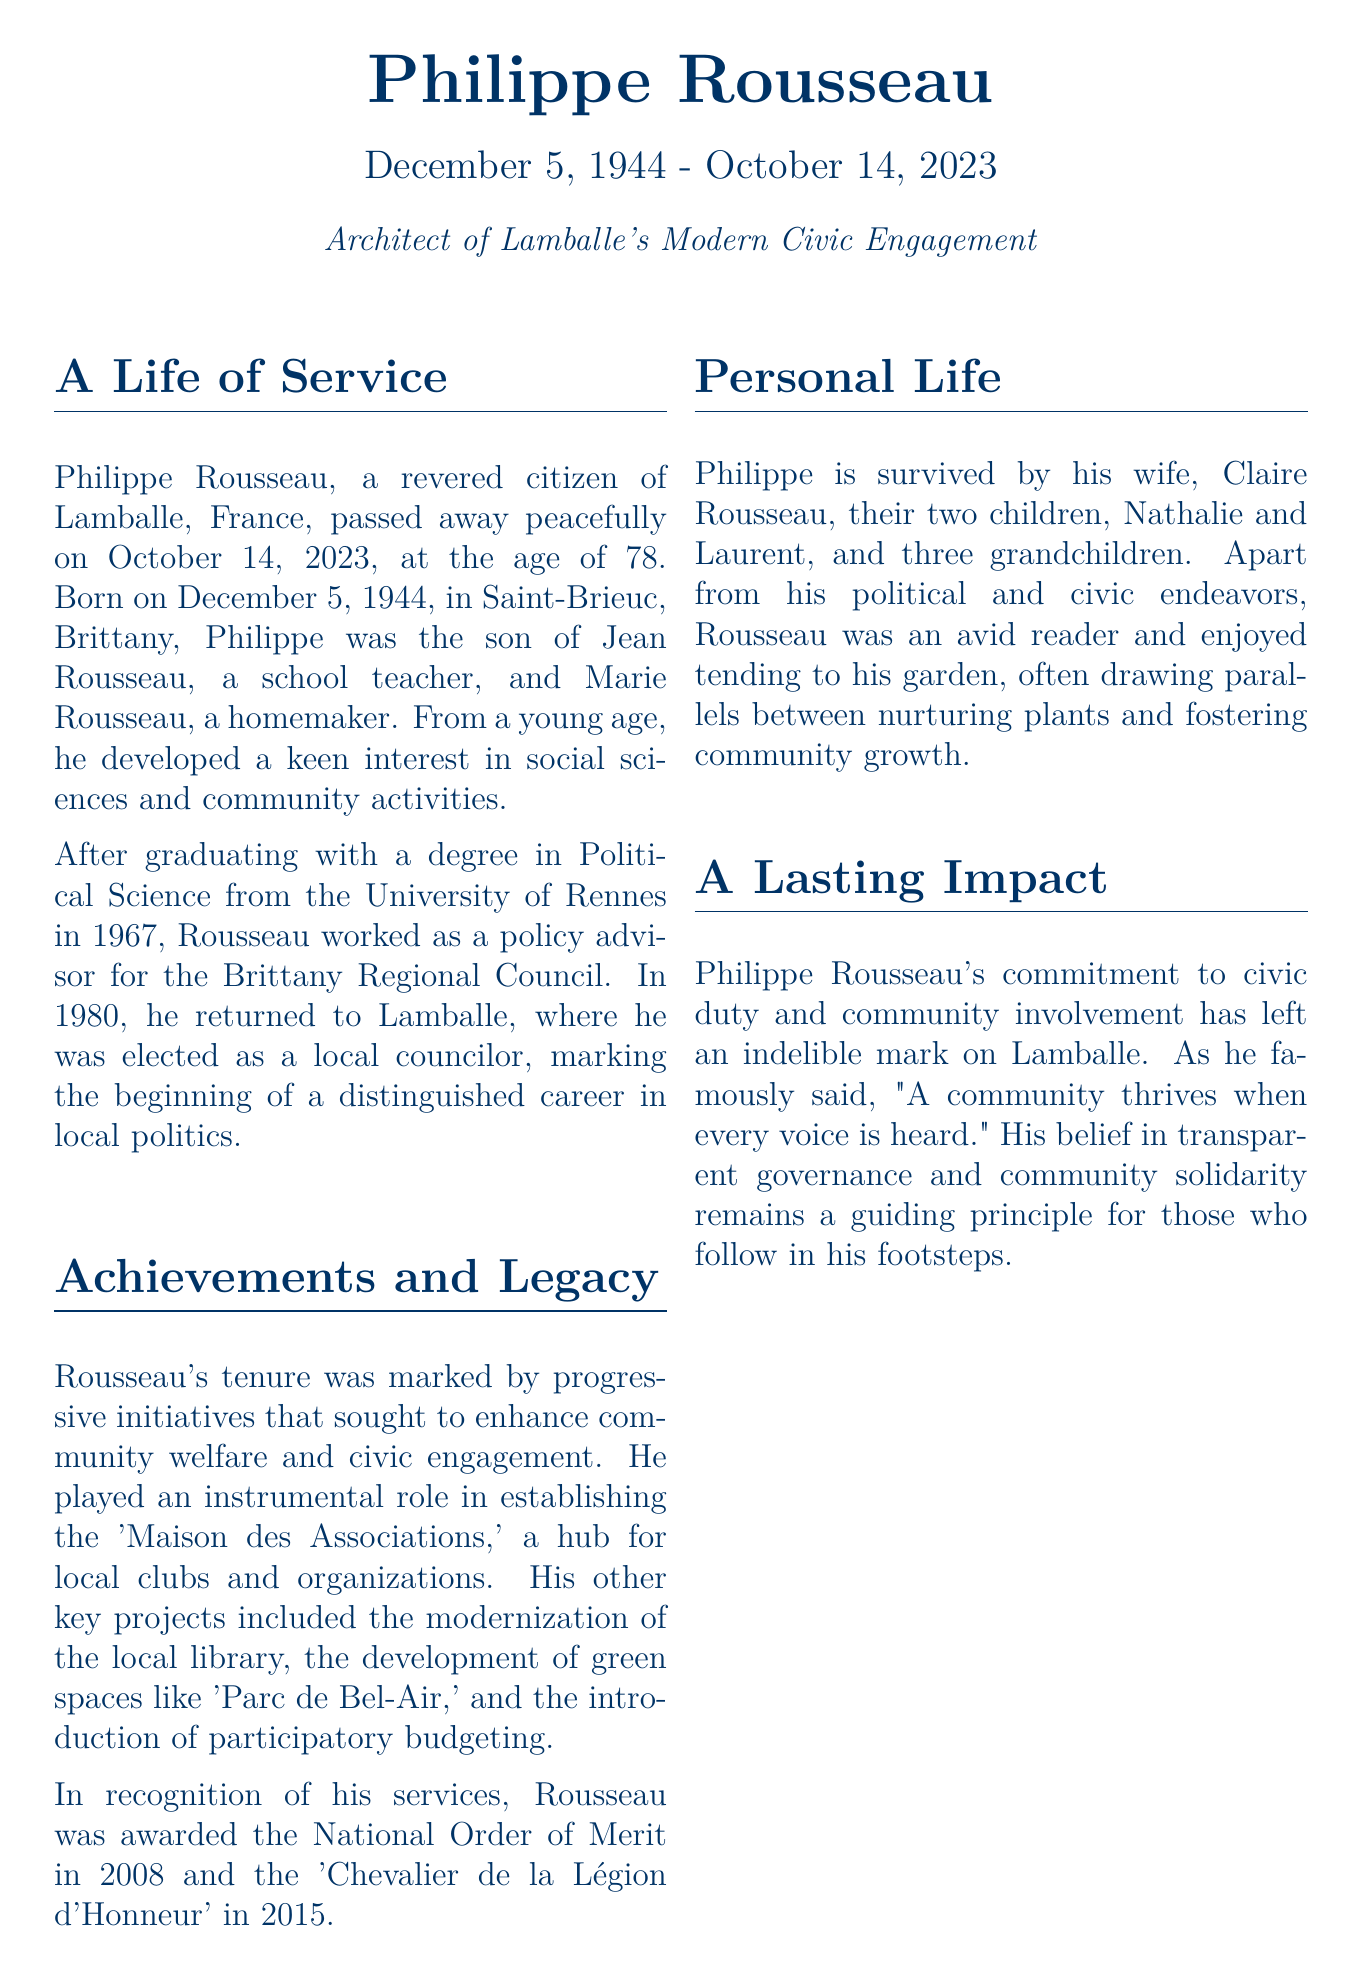What is Philippe Rousseau's date of birth? Philippe Rousseau was born on December 5, 1944.
Answer: December 5, 1944 What position did Philippe Rousseau hold after returning to Lamballe? After returning to Lamballe in 1980, Rousseau was elected as a local councilor.
Answer: Local councilor Which awards were Philippe Rousseau honored with? He was awarded the National Order of Merit in 2008 and the 'Chevalier de la Légion d'Honneur' in 2015.
Answer: National Order of Merit, Chevalier de la Légion d'Honneur What was the purpose of the 'Maison des Associations'? The 'Maison des Associations' served as a hub for local clubs and organizations.
Answer: Hub for local clubs and organizations How many grandchildren did Philippe Rousseau have? Philippe Rousseau had three grandchildren.
Answer: Three What did Philippe Rousseau famously say about communities? He said, "A community thrives when every voice is heard."
Answer: A community thrives when every voice is heard Where will the memorial service for Philippe Rousseau be held? The memorial service will be held at the 'Maison des Associations'.
Answer: Maison des Associations What other activity did Philippe Rousseau enjoy besides politics? He enjoyed tending to his garden.
Answer: Tending to his garden What was the year when Philippe Rousseau passed away? Philippe Rousseau passed away on October 14, 2023.
Answer: October 14, 2023 